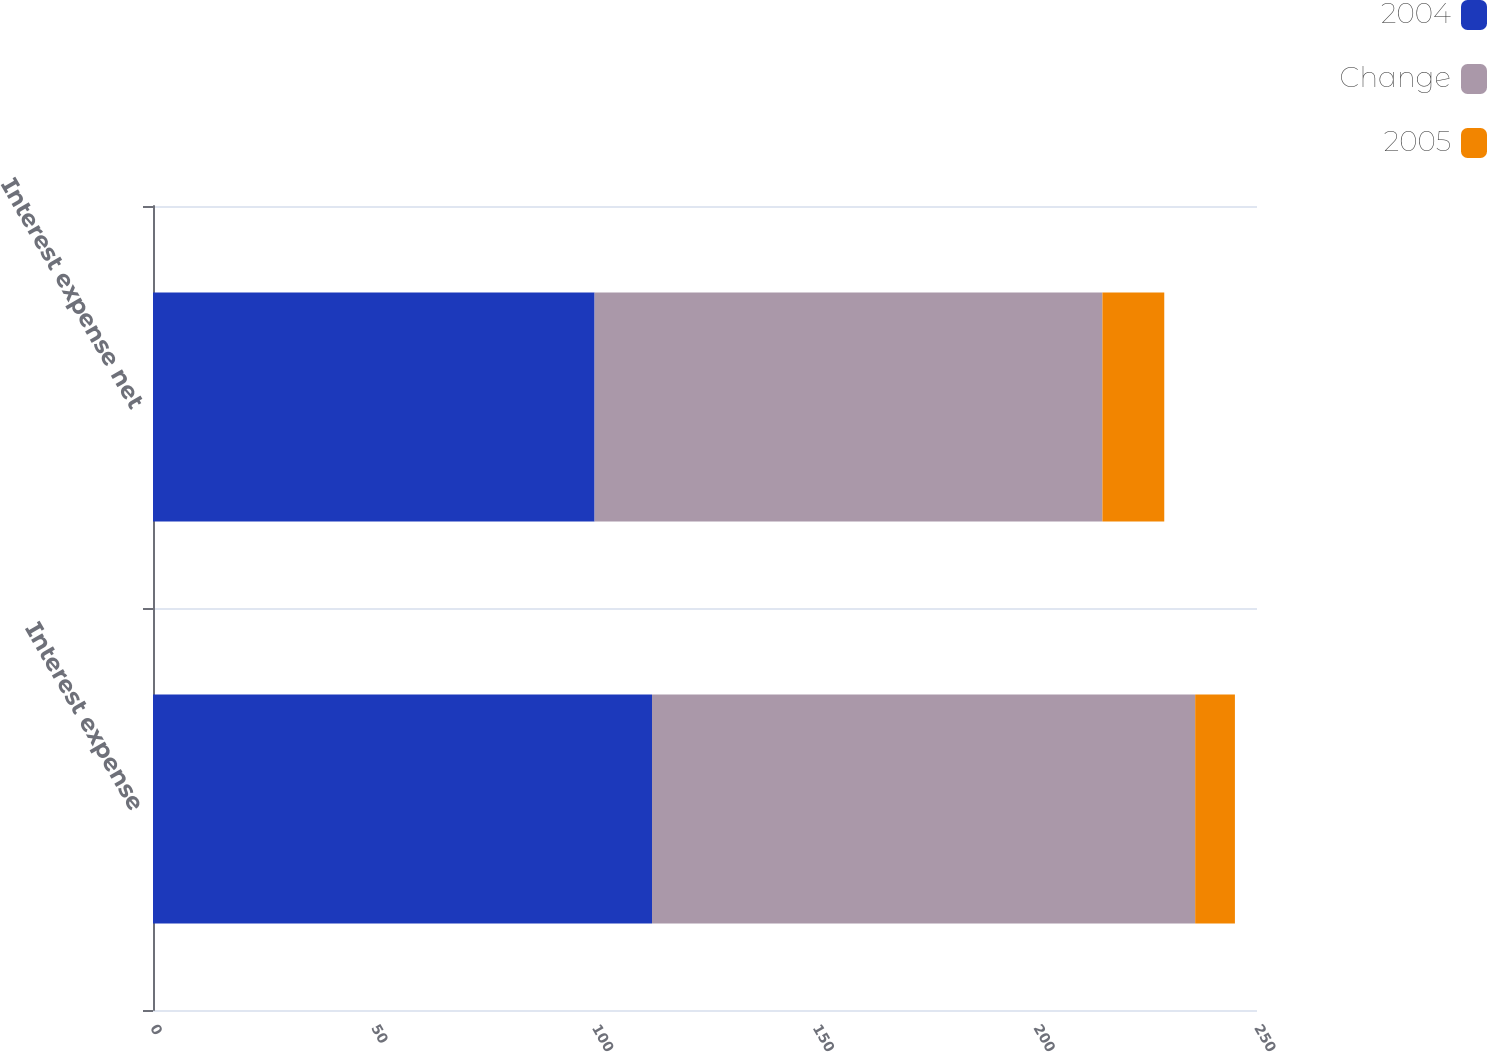Convert chart. <chart><loc_0><loc_0><loc_500><loc_500><stacked_bar_chart><ecel><fcel>Interest expense<fcel>Interest expense net<nl><fcel>2004<fcel>113<fcel>100<nl><fcel>Change<fcel>123<fcel>115<nl><fcel>2005<fcel>9<fcel>14<nl></chart> 